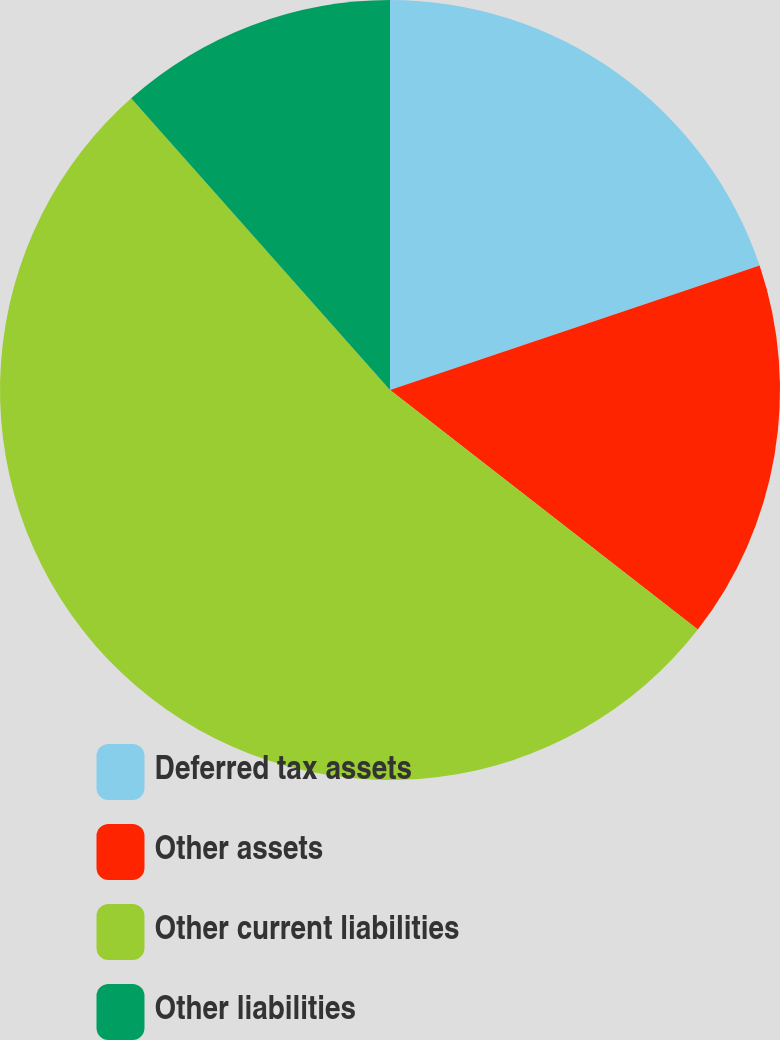<chart> <loc_0><loc_0><loc_500><loc_500><pie_chart><fcel>Deferred tax assets<fcel>Other assets<fcel>Other current liabilities<fcel>Other liabilities<nl><fcel>19.83%<fcel>15.69%<fcel>52.92%<fcel>11.55%<nl></chart> 